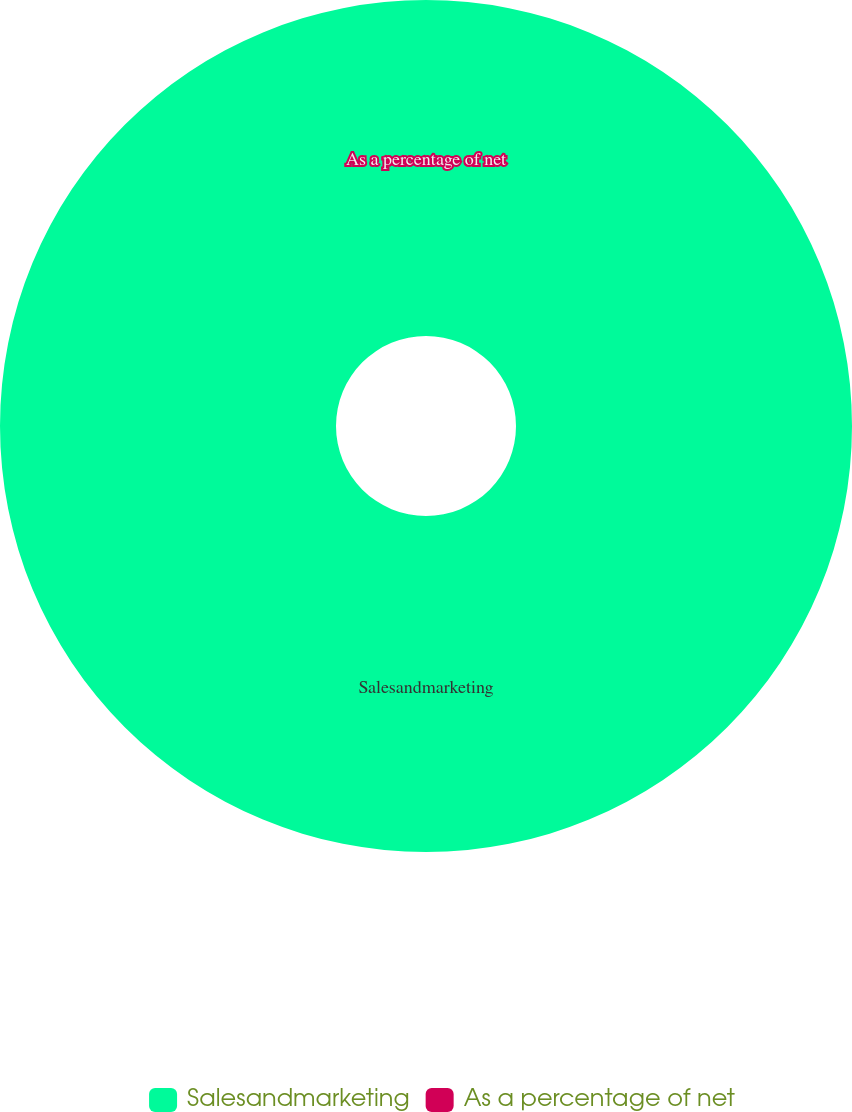<chart> <loc_0><loc_0><loc_500><loc_500><pie_chart><fcel>Salesandmarketing<fcel>As a percentage of net<nl><fcel>100.0%<fcel>0.0%<nl></chart> 